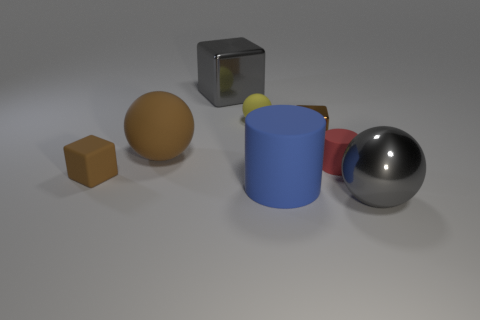How many brown blocks must be subtracted to get 1 brown blocks? 1 Subtract 0 green cylinders. How many objects are left? 8 Subtract all cylinders. How many objects are left? 6 Subtract 2 cylinders. How many cylinders are left? 0 Subtract all brown balls. Subtract all blue cylinders. How many balls are left? 2 Subtract all blue cylinders. How many red spheres are left? 0 Subtract all large brown objects. Subtract all blue cylinders. How many objects are left? 6 Add 8 gray spheres. How many gray spheres are left? 9 Add 1 small matte objects. How many small matte objects exist? 4 Add 2 small green rubber cylinders. How many objects exist? 10 